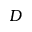<formula> <loc_0><loc_0><loc_500><loc_500>D</formula> 